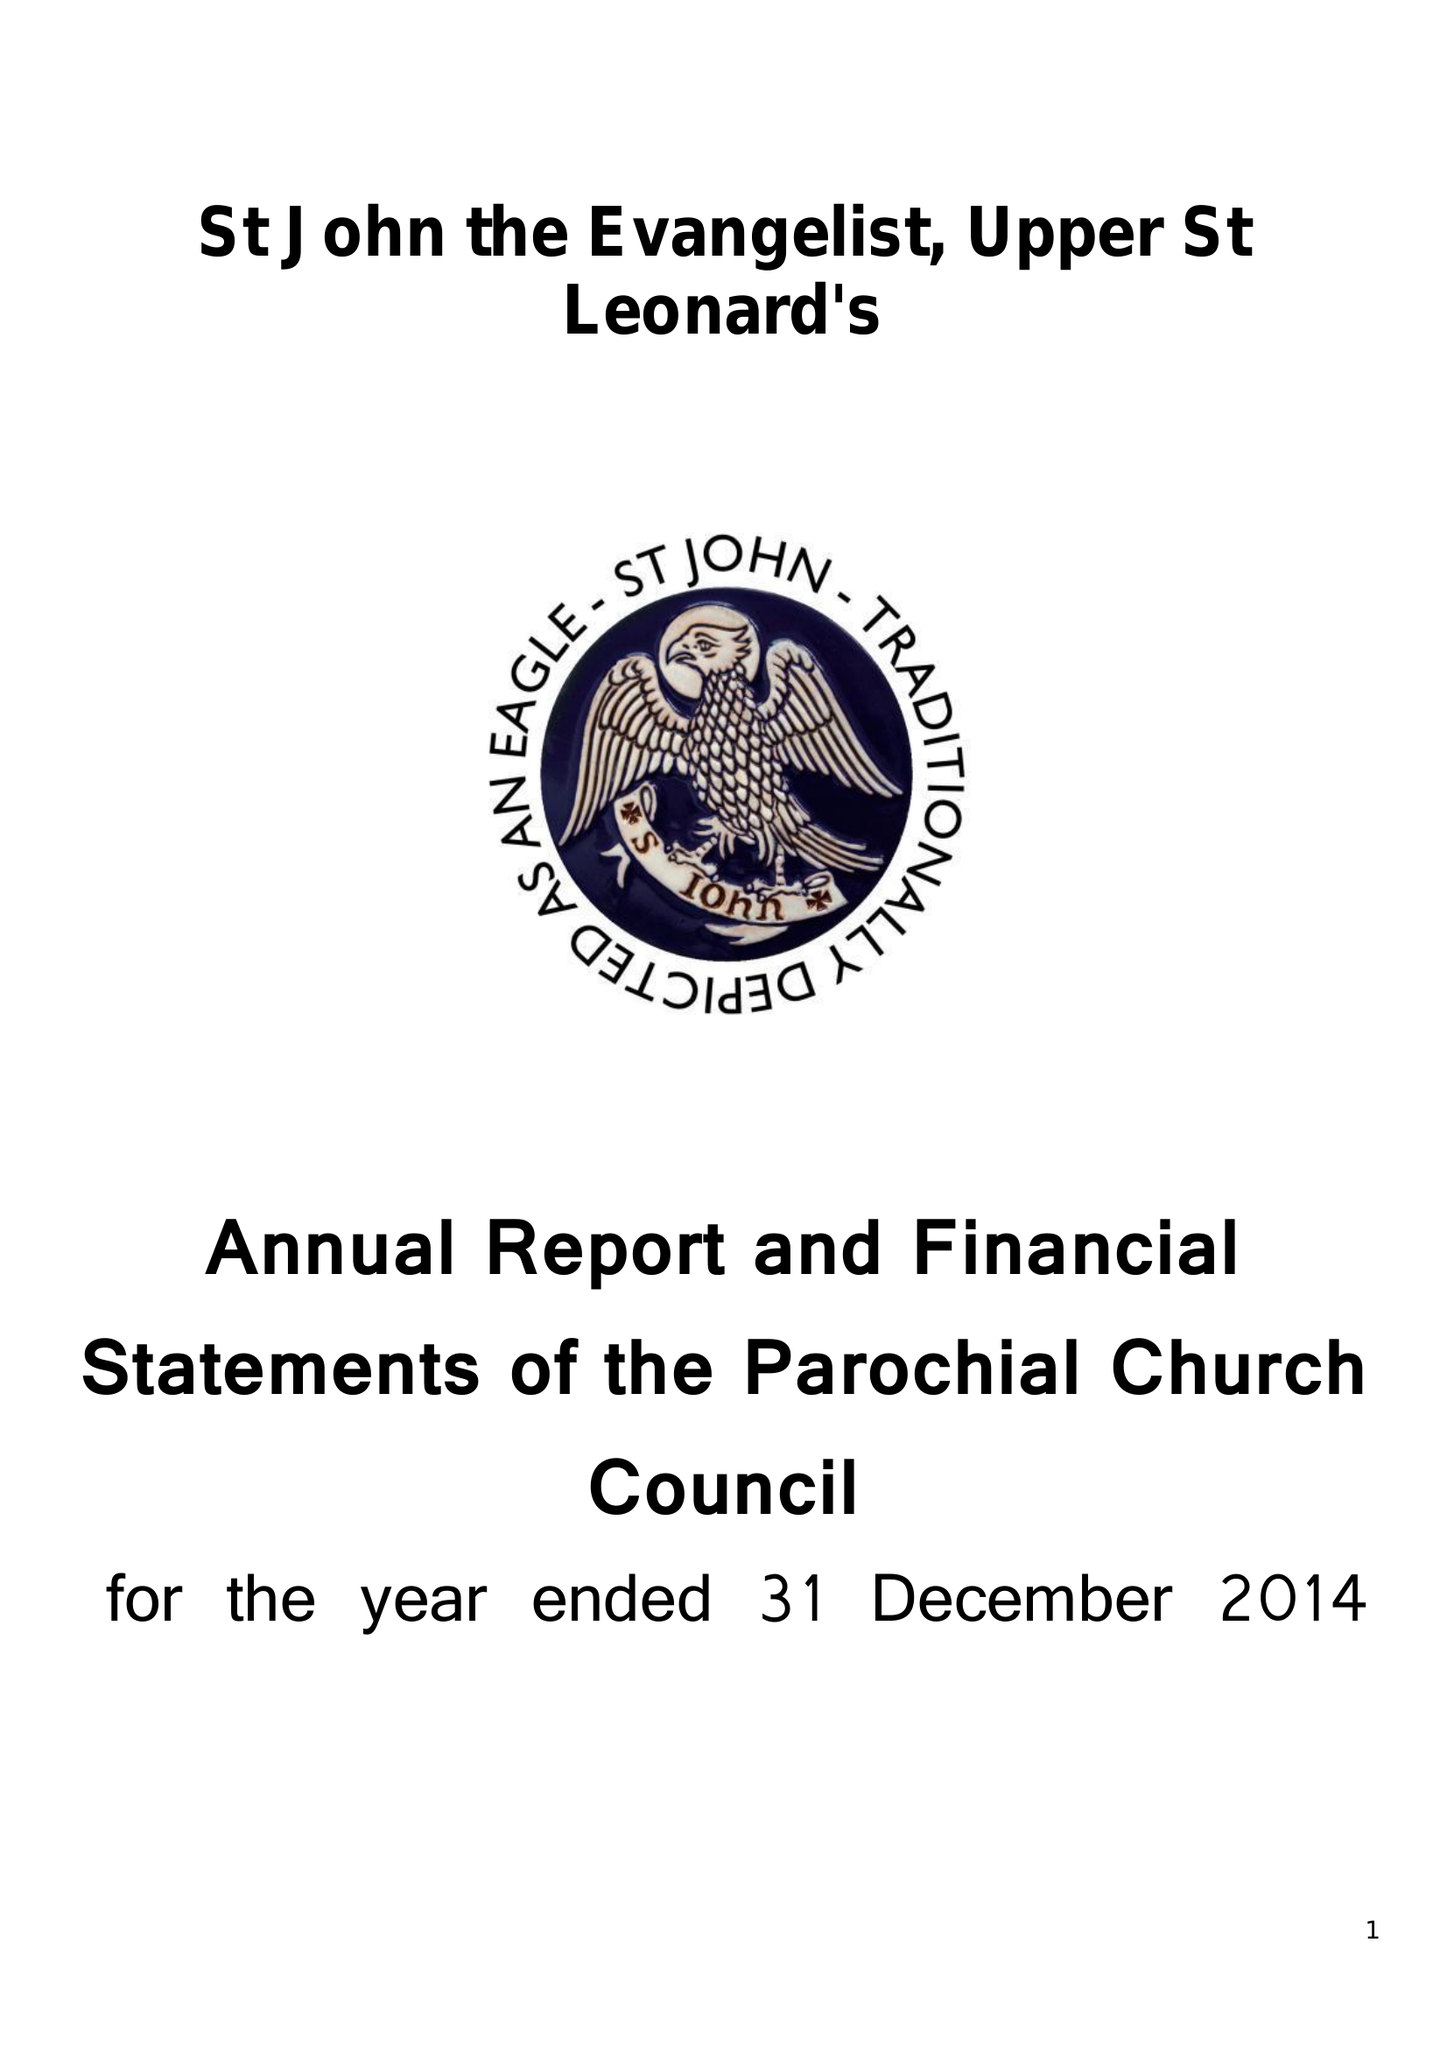What is the value for the income_annually_in_british_pounds?
Answer the question using a single word or phrase. 98405.00 